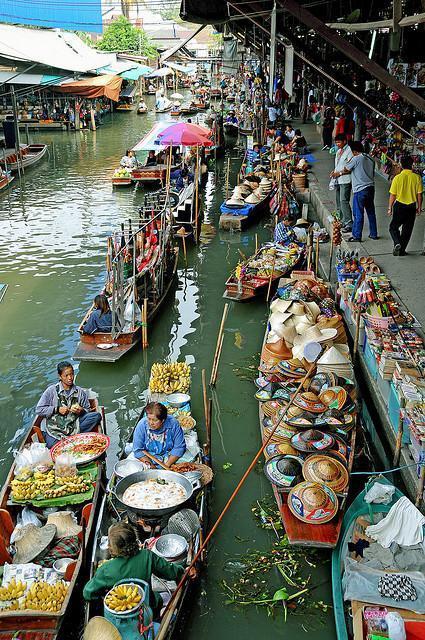How many boats are capsized?
Give a very brief answer. 0. How many people are visible?
Give a very brief answer. 6. How many boats can be seen?
Give a very brief answer. 7. 